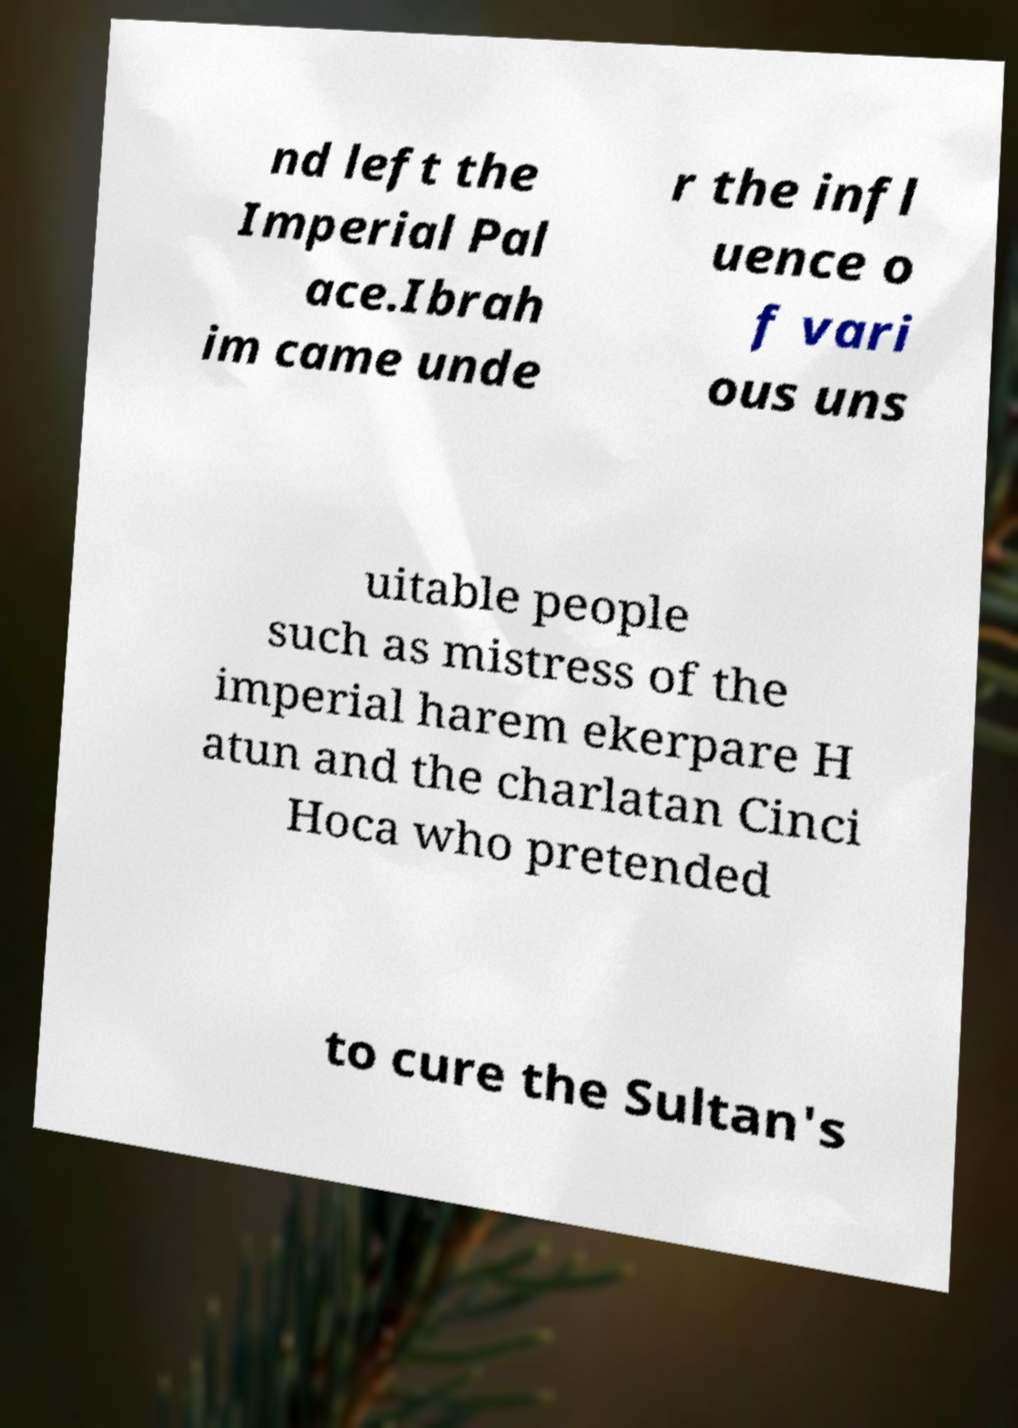What messages or text are displayed in this image? I need them in a readable, typed format. nd left the Imperial Pal ace.Ibrah im came unde r the infl uence o f vari ous uns uitable people such as mistress of the imperial harem ekerpare H atun and the charlatan Cinci Hoca who pretended to cure the Sultan's 